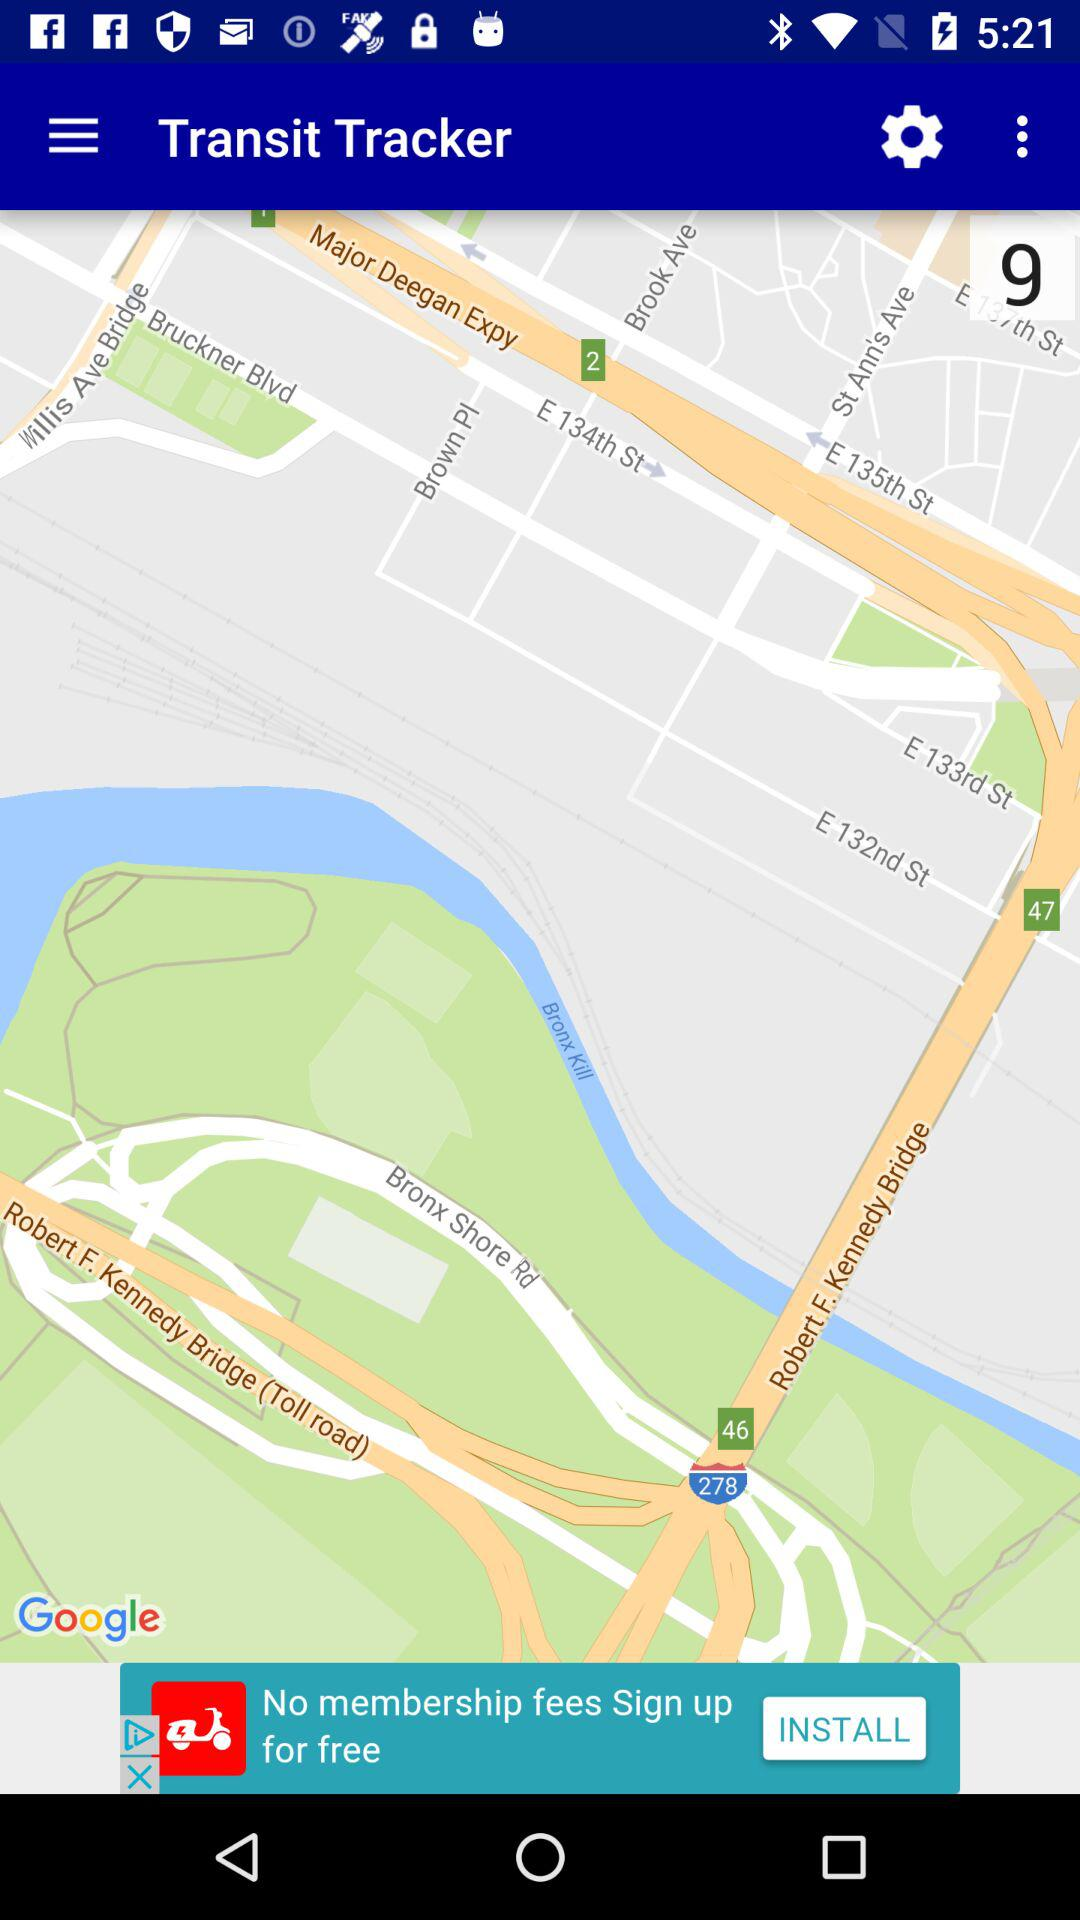What is the application name? The application name is "Transit Tracker". 